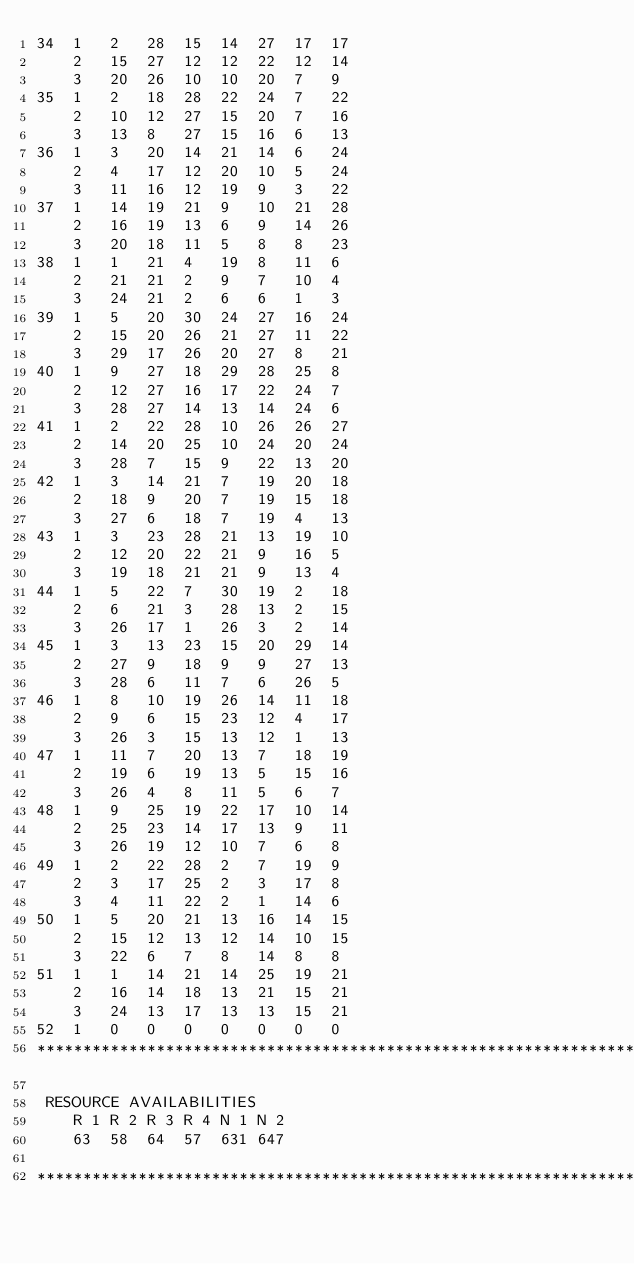Convert code to text. <code><loc_0><loc_0><loc_500><loc_500><_ObjectiveC_>34	1	2	28	15	14	27	17	17	
	2	15	27	12	12	22	12	14	
	3	20	26	10	10	20	7	9	
35	1	2	18	28	22	24	7	22	
	2	10	12	27	15	20	7	16	
	3	13	8	27	15	16	6	13	
36	1	3	20	14	21	14	6	24	
	2	4	17	12	20	10	5	24	
	3	11	16	12	19	9	3	22	
37	1	14	19	21	9	10	21	28	
	2	16	19	13	6	9	14	26	
	3	20	18	11	5	8	8	23	
38	1	1	21	4	19	8	11	6	
	2	21	21	2	9	7	10	4	
	3	24	21	2	6	6	1	3	
39	1	5	20	30	24	27	16	24	
	2	15	20	26	21	27	11	22	
	3	29	17	26	20	27	8	21	
40	1	9	27	18	29	28	25	8	
	2	12	27	16	17	22	24	7	
	3	28	27	14	13	14	24	6	
41	1	2	22	28	10	26	26	27	
	2	14	20	25	10	24	20	24	
	3	28	7	15	9	22	13	20	
42	1	3	14	21	7	19	20	18	
	2	18	9	20	7	19	15	18	
	3	27	6	18	7	19	4	13	
43	1	3	23	28	21	13	19	10	
	2	12	20	22	21	9	16	5	
	3	19	18	21	21	9	13	4	
44	1	5	22	7	30	19	2	18	
	2	6	21	3	28	13	2	15	
	3	26	17	1	26	3	2	14	
45	1	3	13	23	15	20	29	14	
	2	27	9	18	9	9	27	13	
	3	28	6	11	7	6	26	5	
46	1	8	10	19	26	14	11	18	
	2	9	6	15	23	12	4	17	
	3	26	3	15	13	12	1	13	
47	1	11	7	20	13	7	18	19	
	2	19	6	19	13	5	15	16	
	3	26	4	8	11	5	6	7	
48	1	9	25	19	22	17	10	14	
	2	25	23	14	17	13	9	11	
	3	26	19	12	10	7	6	8	
49	1	2	22	28	2	7	19	9	
	2	3	17	25	2	3	17	8	
	3	4	11	22	2	1	14	6	
50	1	5	20	21	13	16	14	15	
	2	15	12	13	12	14	10	15	
	3	22	6	7	8	14	8	8	
51	1	1	14	21	14	25	19	21	
	2	16	14	18	13	21	15	21	
	3	24	13	17	13	13	15	21	
52	1	0	0	0	0	0	0	0	
************************************************************************

 RESOURCE AVAILABILITIES 
	R 1	R 2	R 3	R 4	N 1	N 2
	63	58	64	57	631	647

************************************************************************
</code> 